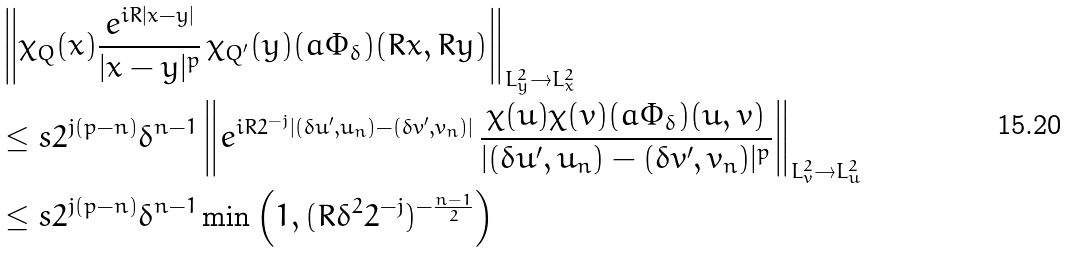Convert formula to latex. <formula><loc_0><loc_0><loc_500><loc_500>& \left \| \chi _ { Q } ( x ) \frac { e ^ { i R | x - y | } } { | x - y | ^ { p } } \, \chi _ { Q ^ { \prime } } ( y ) ( a \Phi _ { \delta } ) ( R x , R y ) \right \| _ { L ^ { 2 } _ { y } \to L _ { x } ^ { 2 } } \\ & \leq s 2 ^ { j ( p - n ) } \delta ^ { n - 1 } \left \| e ^ { i R 2 ^ { - j } | ( \delta u ^ { \prime } , u _ { n } ) - ( \delta v ^ { \prime } , v _ { n } ) | } \, \frac { \chi ( u ) \chi ( v ) ( a \Phi _ { \delta } ) ( u , v ) } { | ( \delta u ^ { \prime } , u _ { n } ) - ( \delta v ^ { \prime } , v _ { n } ) | ^ { p } } \right \| _ { L _ { v } ^ { 2 } \to L _ { u } ^ { 2 } } \\ & \leq s 2 ^ { j ( p - n ) } \delta ^ { n - 1 } \min \left ( 1 , ( R \delta ^ { 2 } 2 ^ { - j } ) ^ { - \frac { n - 1 } { 2 } } \right )</formula> 